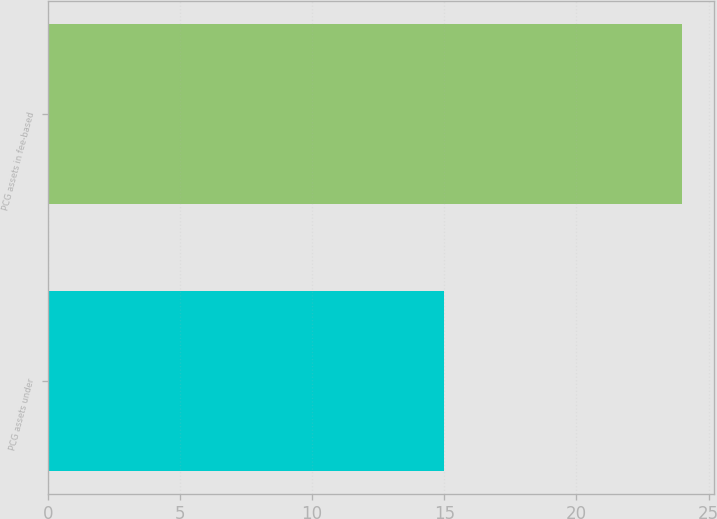<chart> <loc_0><loc_0><loc_500><loc_500><bar_chart><fcel>PCG assets under<fcel>PCG assets in fee-based<nl><fcel>15<fcel>24<nl></chart> 